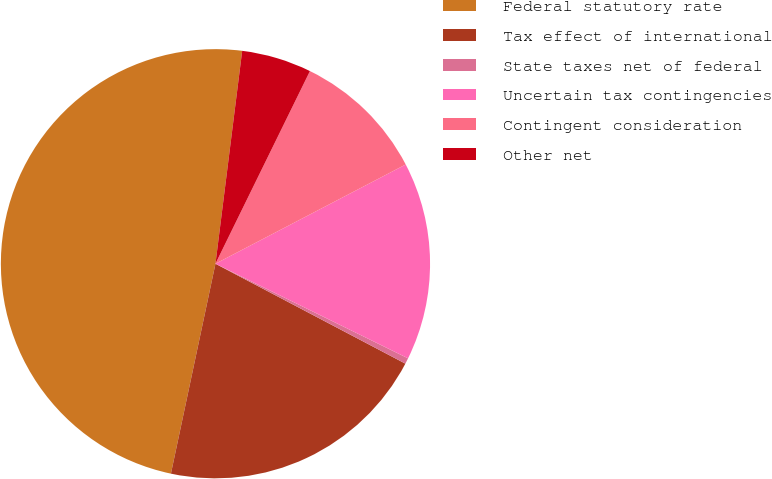Convert chart. <chart><loc_0><loc_0><loc_500><loc_500><pie_chart><fcel>Federal statutory rate<fcel>Tax effect of international<fcel>State taxes net of federal<fcel>Uncertain tax contingencies<fcel>Contingent consideration<fcel>Other net<nl><fcel>48.66%<fcel>20.62%<fcel>0.44%<fcel>14.92%<fcel>10.09%<fcel>5.27%<nl></chart> 